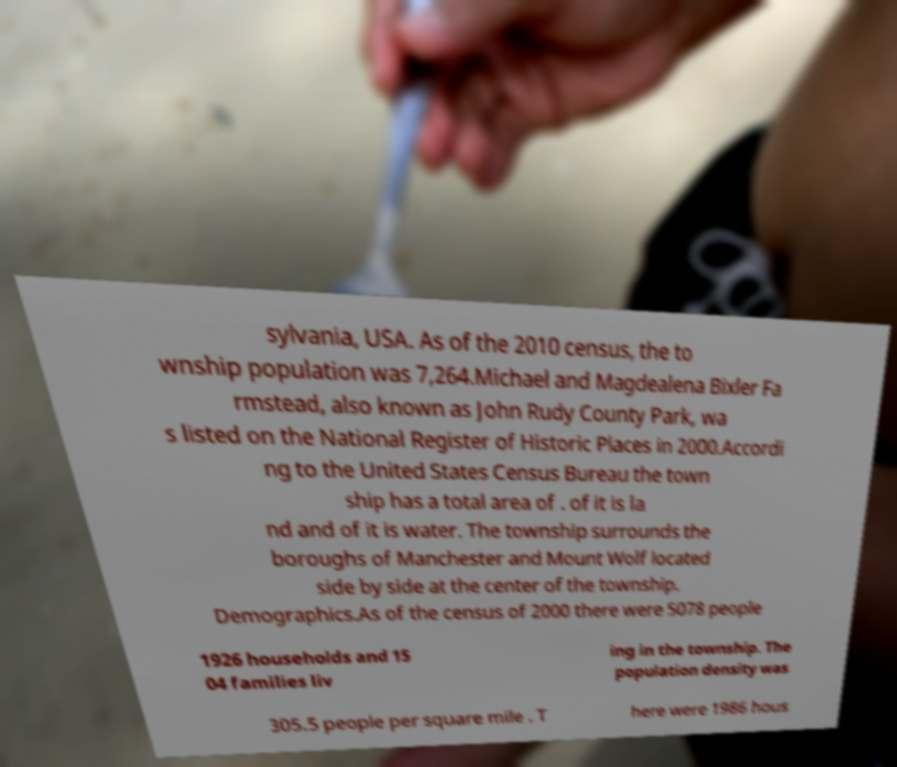What messages or text are displayed in this image? I need them in a readable, typed format. sylvania, USA. As of the 2010 census, the to wnship population was 7,264.Michael and Magdealena Bixler Fa rmstead, also known as John Rudy County Park, wa s listed on the National Register of Historic Places in 2000.Accordi ng to the United States Census Bureau the town ship has a total area of . of it is la nd and of it is water. The township surrounds the boroughs of Manchester and Mount Wolf located side by side at the center of the township. Demographics.As of the census of 2000 there were 5078 people 1926 households and 15 04 families liv ing in the township. The population density was 305.5 people per square mile . T here were 1986 hous 